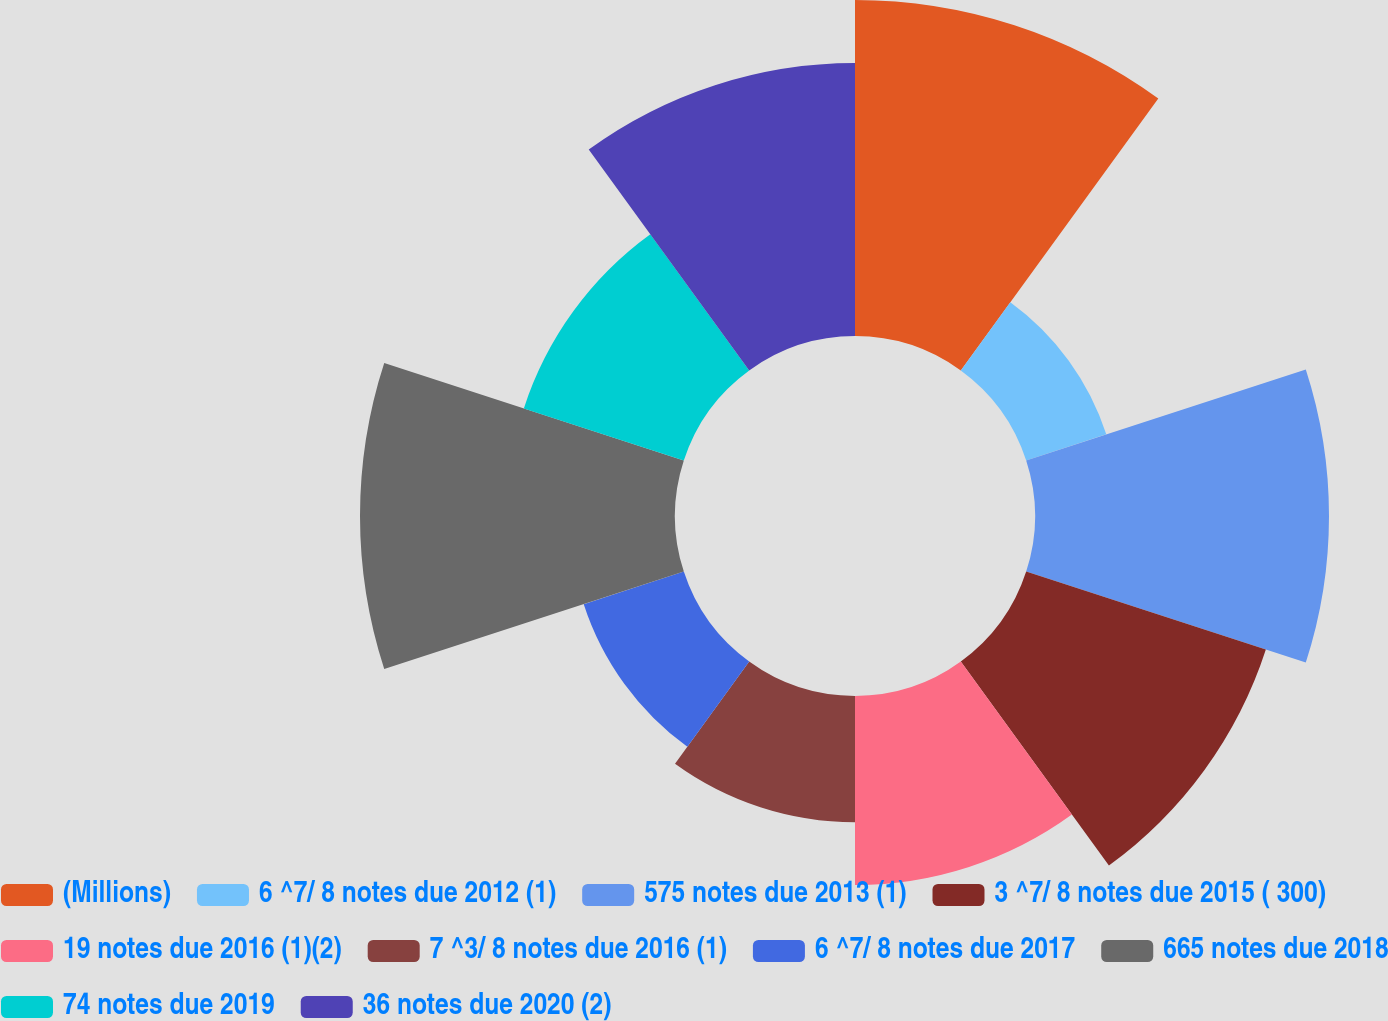Convert chart to OTSL. <chart><loc_0><loc_0><loc_500><loc_500><pie_chart><fcel>(Millions)<fcel>6 ^7/ 8 notes due 2012 (1)<fcel>575 notes due 2013 (1)<fcel>3 ^7/ 8 notes due 2015 ( 300)<fcel>19 notes due 2016 (1)(2)<fcel>7 ^3/ 8 notes due 2016 (1)<fcel>6 ^7/ 8 notes due 2017<fcel>665 notes due 2018<fcel>74 notes due 2019<fcel>36 notes due 2020 (2)<nl><fcel>15.68%<fcel>3.93%<fcel>13.72%<fcel>11.76%<fcel>8.82%<fcel>5.89%<fcel>4.91%<fcel>14.7%<fcel>7.85%<fcel>12.74%<nl></chart> 